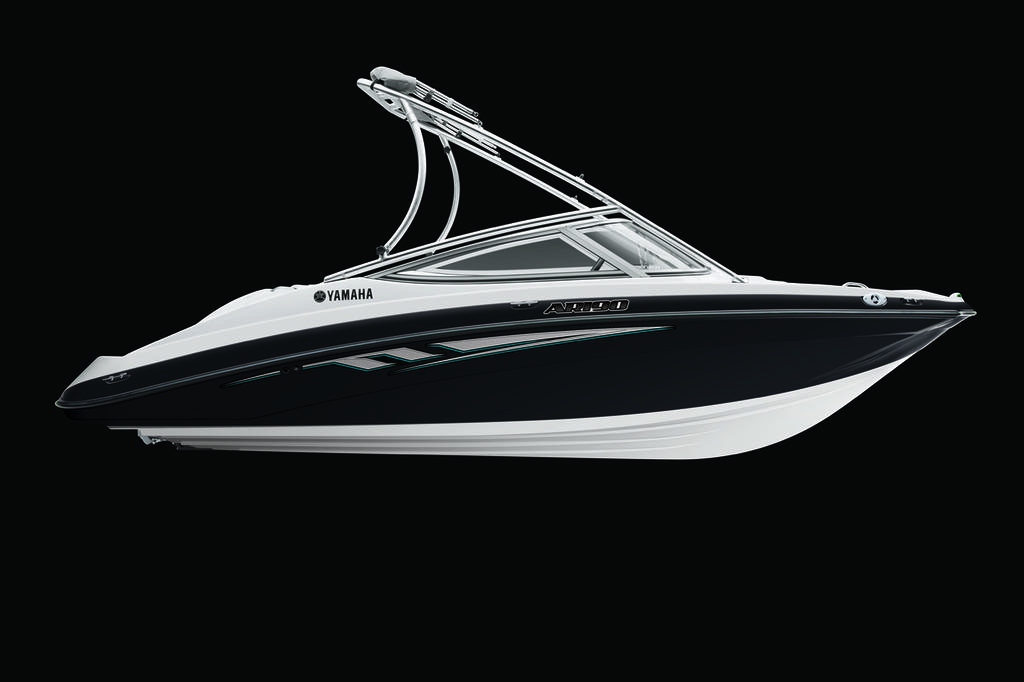What is the main subject of the image? There is a boat in the image. What color is the background of the image? The background of the image is black in color. Can you make any assumptions about the time of day based on the image? The image may have been taken during the night, given the black background. What type of bag is your grandmother holding in the image? There is no grandmother or bag present in the image; it only features a boat and a black background. 